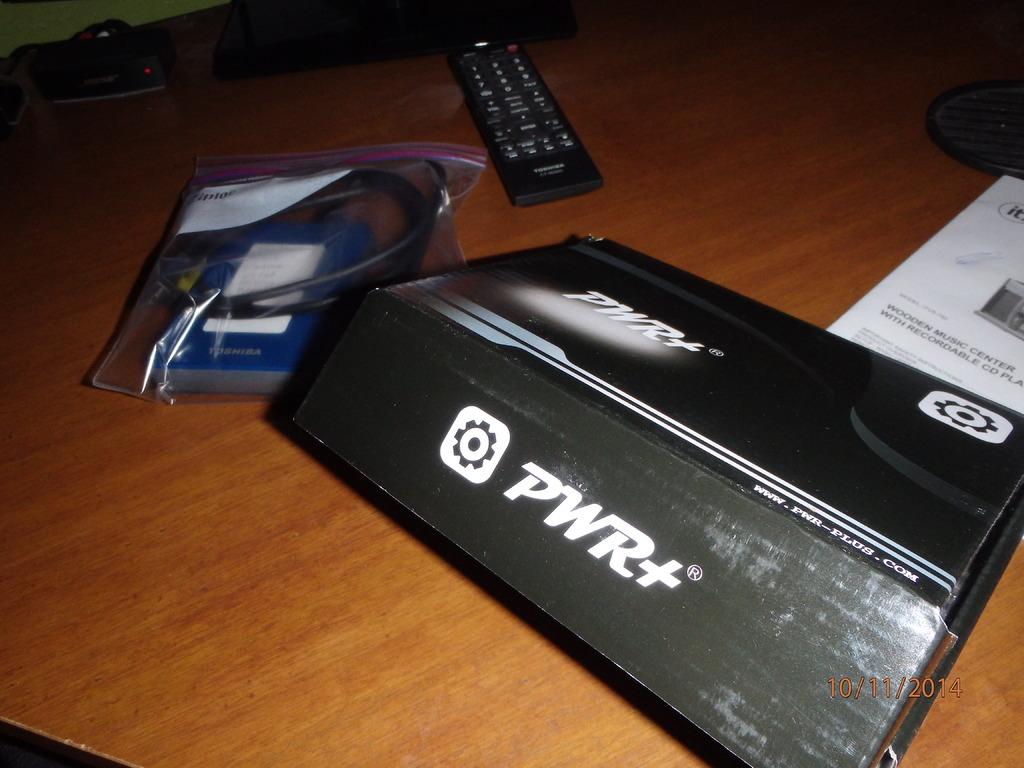What device is in the box?
Keep it short and to the point. Pwr+. 